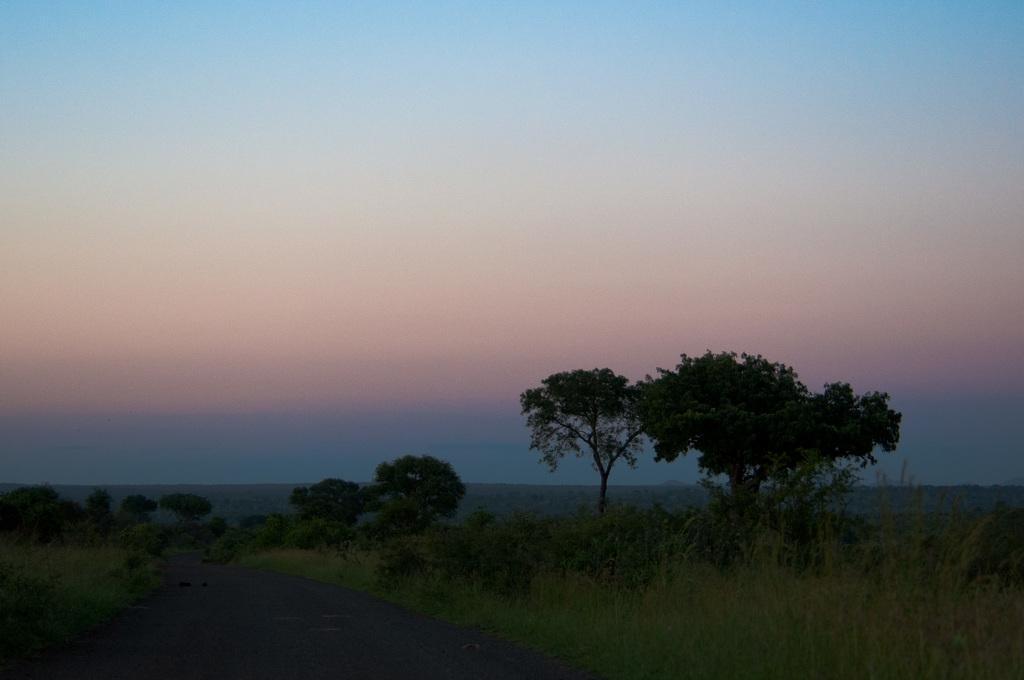Can you describe this image briefly? In this image we can see there is a road in the middle and there are trees on either side of the road. At the top there is sky. Beside the road there is grass and small plants. 